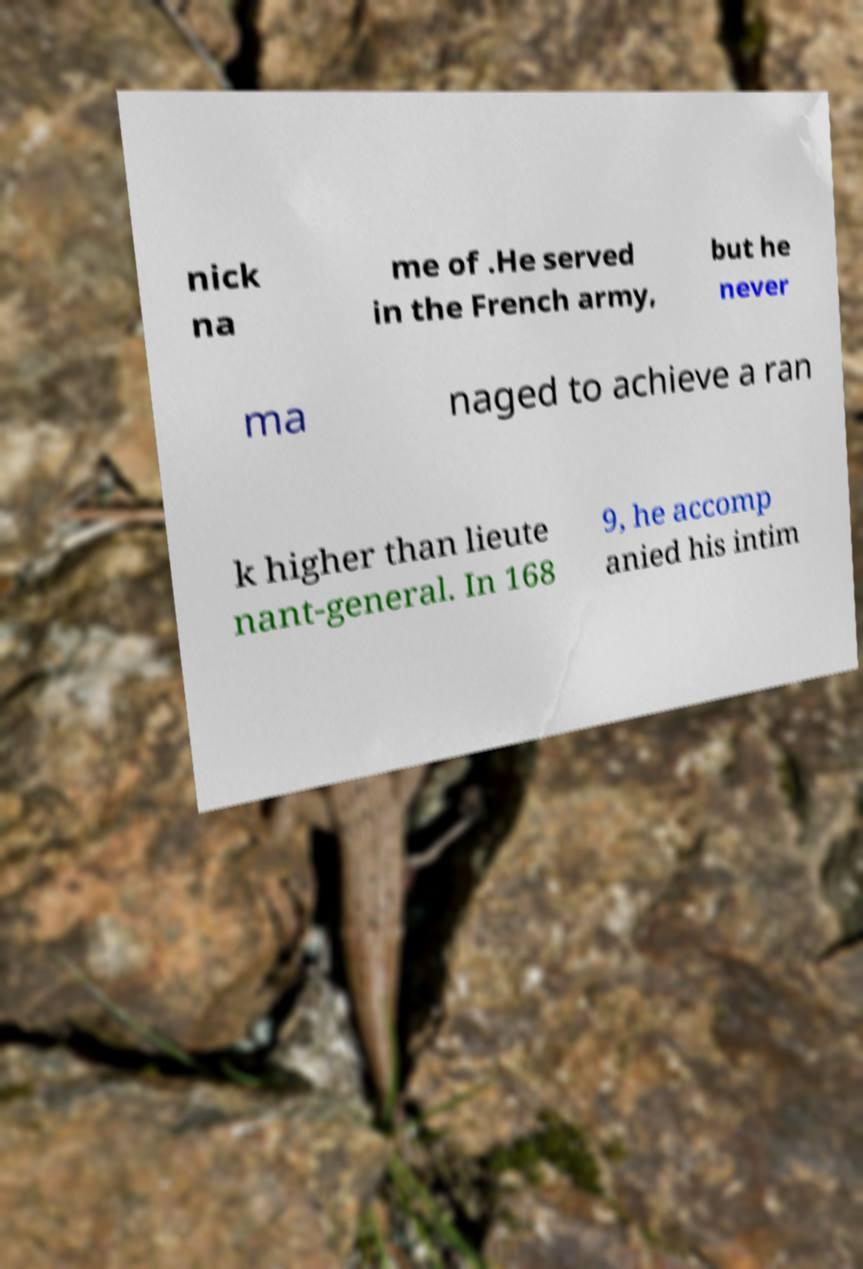Please identify and transcribe the text found in this image. nick na me of .He served in the French army, but he never ma naged to achieve a ran k higher than lieute nant-general. In 168 9, he accomp anied his intim 